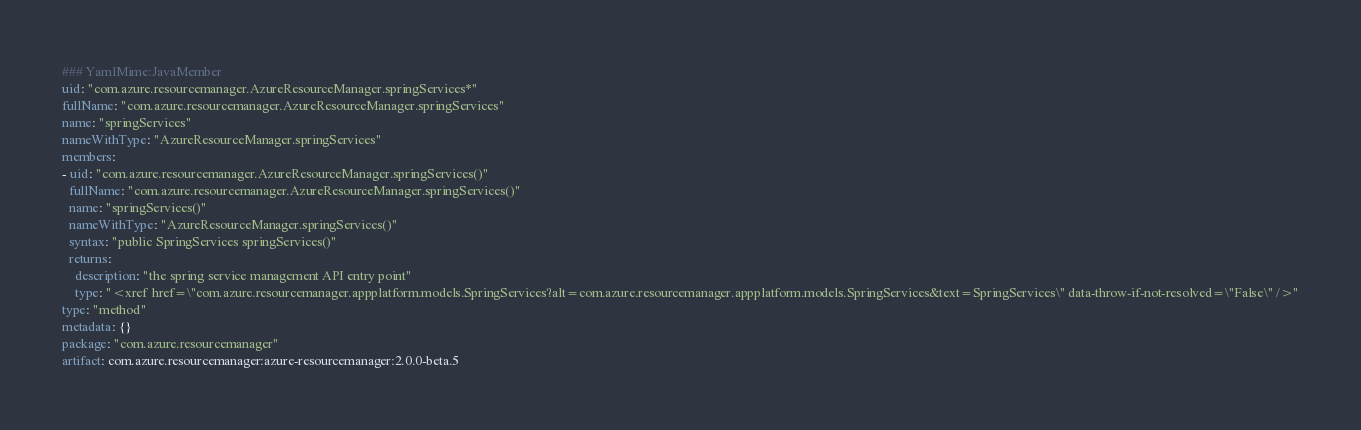Convert code to text. <code><loc_0><loc_0><loc_500><loc_500><_YAML_>### YamlMime:JavaMember
uid: "com.azure.resourcemanager.AzureResourceManager.springServices*"
fullName: "com.azure.resourcemanager.AzureResourceManager.springServices"
name: "springServices"
nameWithType: "AzureResourceManager.springServices"
members:
- uid: "com.azure.resourcemanager.AzureResourceManager.springServices()"
  fullName: "com.azure.resourcemanager.AzureResourceManager.springServices()"
  name: "springServices()"
  nameWithType: "AzureResourceManager.springServices()"
  syntax: "public SpringServices springServices()"
  returns:
    description: "the spring service management API entry point"
    type: "<xref href=\"com.azure.resourcemanager.appplatform.models.SpringServices?alt=com.azure.resourcemanager.appplatform.models.SpringServices&text=SpringServices\" data-throw-if-not-resolved=\"False\" />"
type: "method"
metadata: {}
package: "com.azure.resourcemanager"
artifact: com.azure.resourcemanager:azure-resourcemanager:2.0.0-beta.5
</code> 